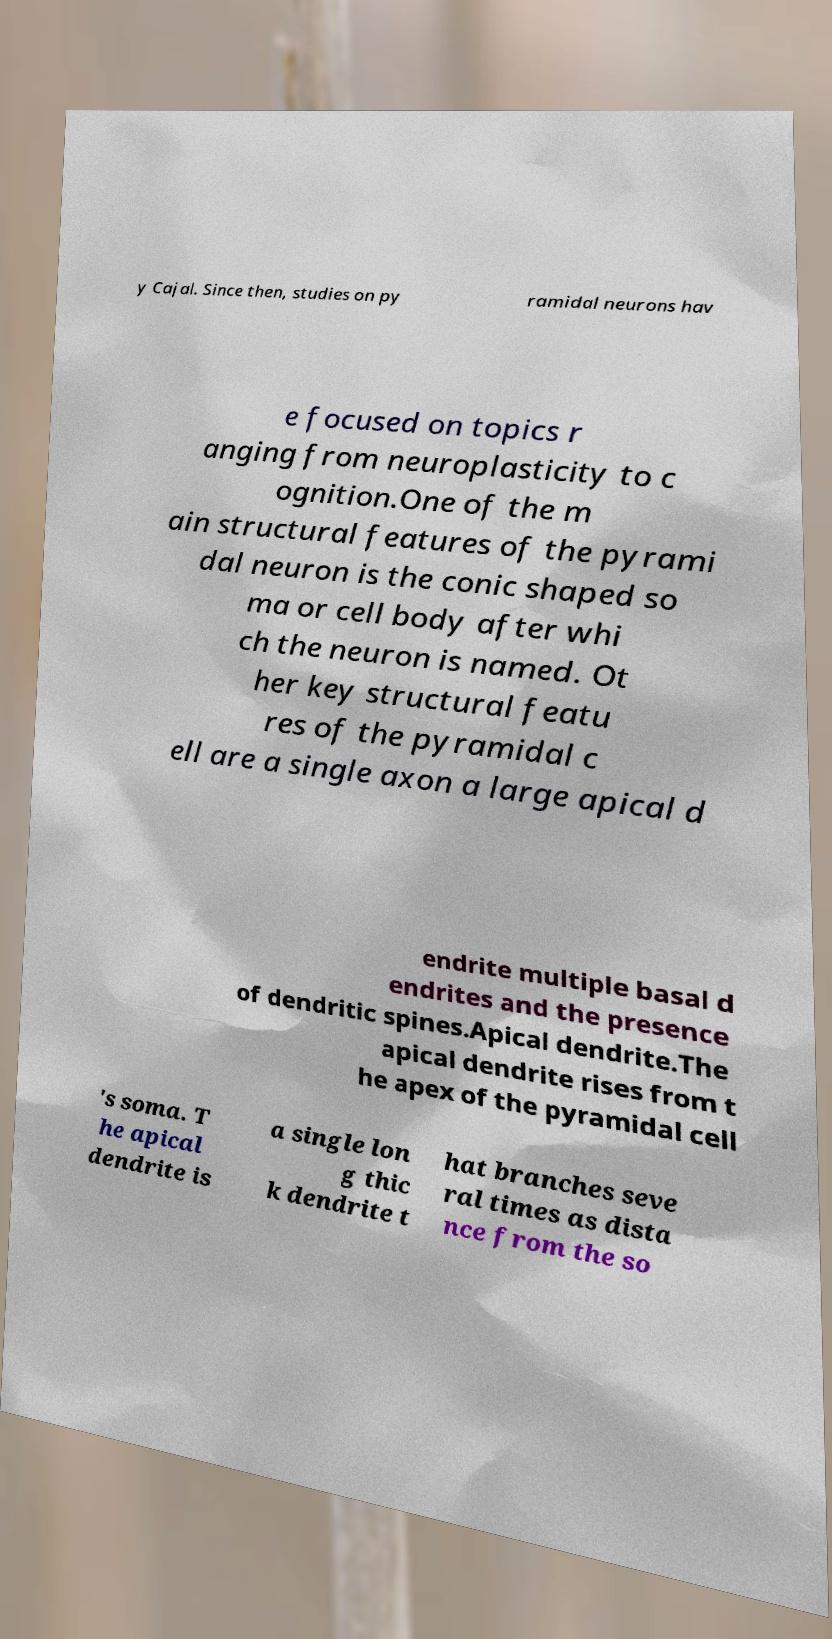Can you read and provide the text displayed in the image?This photo seems to have some interesting text. Can you extract and type it out for me? y Cajal. Since then, studies on py ramidal neurons hav e focused on topics r anging from neuroplasticity to c ognition.One of the m ain structural features of the pyrami dal neuron is the conic shaped so ma or cell body after whi ch the neuron is named. Ot her key structural featu res of the pyramidal c ell are a single axon a large apical d endrite multiple basal d endrites and the presence of dendritic spines.Apical dendrite.The apical dendrite rises from t he apex of the pyramidal cell 's soma. T he apical dendrite is a single lon g thic k dendrite t hat branches seve ral times as dista nce from the so 